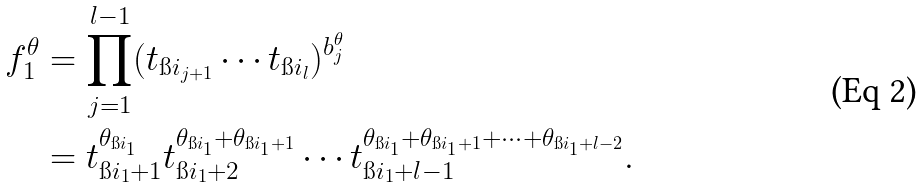<formula> <loc_0><loc_0><loc_500><loc_500>f ^ { \theta } _ { 1 } & = \prod _ { j = 1 } ^ { l - 1 } ( t _ { \i i _ { j + 1 } } \cdots t _ { \i i _ { l } } ) ^ { b _ { j } ^ { \theta } } \\ & = t _ { \i i _ { 1 } + 1 } ^ { \theta _ { \i i _ { 1 } } } t _ { \i i _ { 1 } + 2 } ^ { \theta _ { \i i _ { 1 } } + \theta _ { \i i _ { 1 } + 1 } } \cdots t _ { \i i _ { 1 } + l - 1 } ^ { \theta _ { \i i _ { 1 } } + \theta _ { \i i _ { 1 } + 1 } + \dots + \theta _ { \i i _ { 1 } + l - 2 } } .</formula> 